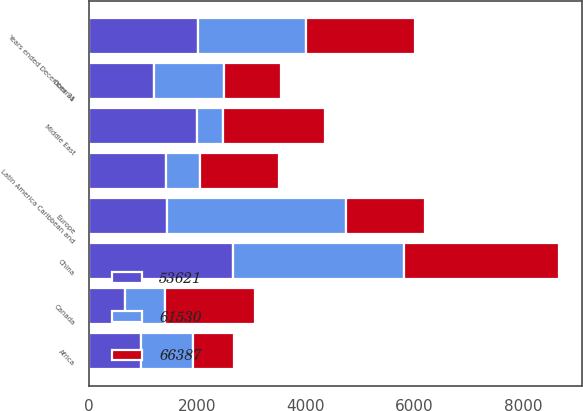Convert chart. <chart><loc_0><loc_0><loc_500><loc_500><stacked_bar_chart><ecel><fcel>Years ended December 31<fcel>China<fcel>Europe<fcel>Middle East<fcel>Oceania<fcel>Africa<fcel>Canada<fcel>Latin America Caribbean and<nl><fcel>66387<fcel>2007<fcel>2853<fcel>1438.5<fcel>1891<fcel>1057<fcel>751<fcel>1653<fcel>1446<nl><fcel>53621<fcel>2006<fcel>2659<fcel>1438.5<fcel>1991<fcel>1206<fcel>967<fcel>660<fcel>1431<nl><fcel>61530<fcel>2005<fcel>3154<fcel>3312<fcel>477<fcel>1283<fcel>961<fcel>748<fcel>629<nl></chart> 